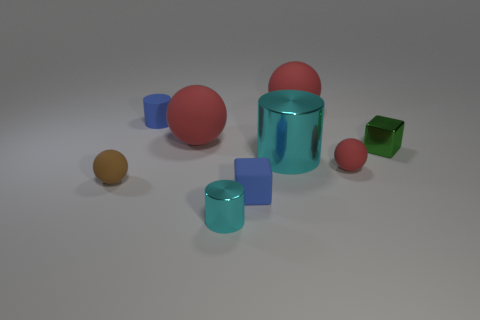Does the matte cylinder have the same color as the rubber cube?
Your answer should be very brief. Yes. Is there anything else that is the same size as the green shiny object?
Make the answer very short. Yes. Are there fewer small spheres behind the tiny red rubber sphere than tiny cylinders on the right side of the tiny cyan cylinder?
Keep it short and to the point. No. Is there anything else that is the same shape as the green object?
Your answer should be compact. Yes. There is a block that is the same color as the small matte cylinder; what is its material?
Your answer should be compact. Rubber. What number of tiny objects are behind the tiny block that is behind the small matte sphere that is on the right side of the rubber cylinder?
Your answer should be very brief. 1. What number of cyan shiny objects are behind the large cylinder?
Give a very brief answer. 0. What number of large cyan things have the same material as the big cylinder?
Make the answer very short. 0. There is a block that is made of the same material as the tiny red thing; what color is it?
Ensure brevity in your answer.  Blue. What material is the red object that is in front of the green cube that is on the right side of the blue rubber object behind the small green thing made of?
Provide a short and direct response. Rubber. 